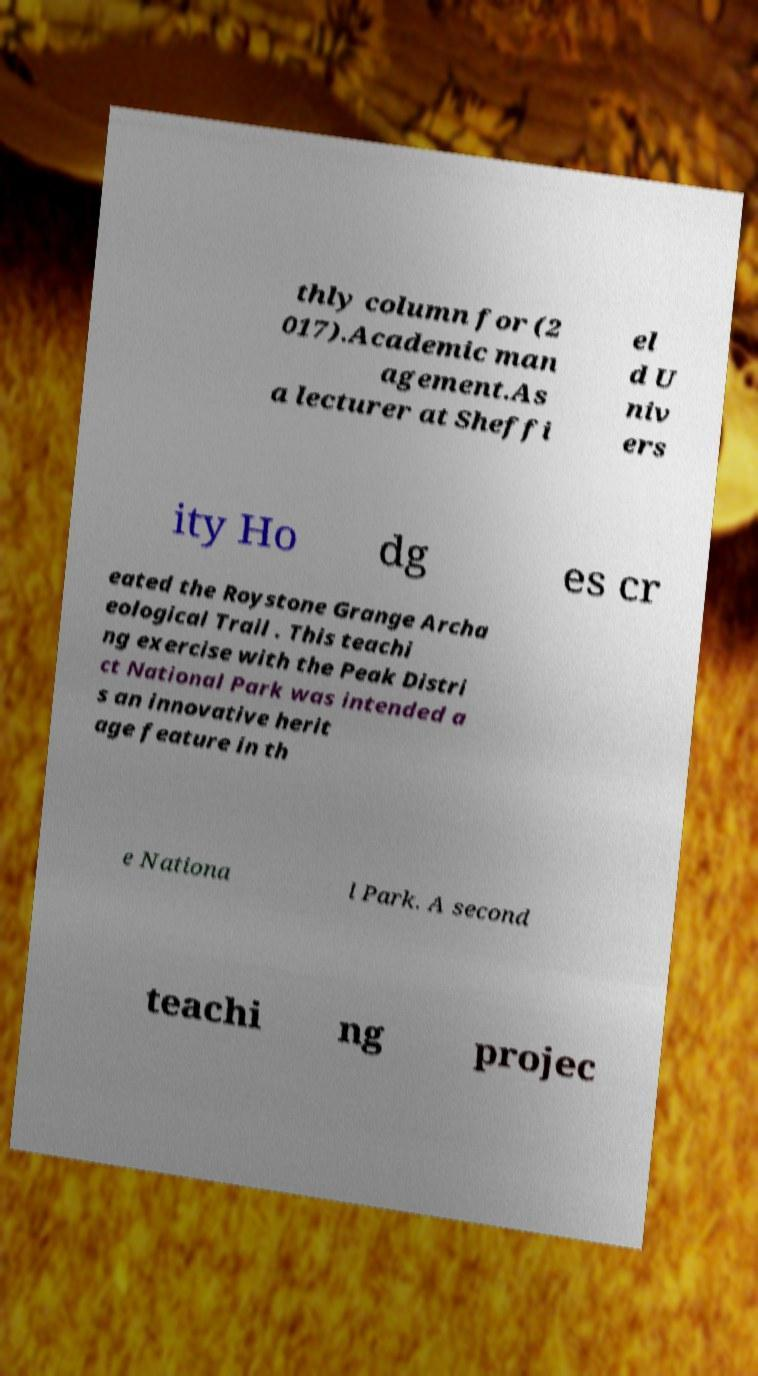Please identify and transcribe the text found in this image. thly column for (2 017).Academic man agement.As a lecturer at Sheffi el d U niv ers ity Ho dg es cr eated the Roystone Grange Archa eological Trail . This teachi ng exercise with the Peak Distri ct National Park was intended a s an innovative herit age feature in th e Nationa l Park. A second teachi ng projec 